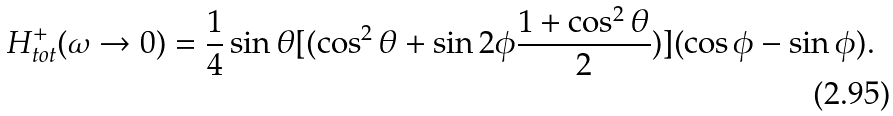Convert formula to latex. <formula><loc_0><loc_0><loc_500><loc_500>H _ { t o t } ^ { + } ( \omega \rightarrow 0 ) = \frac { 1 } { 4 } \sin \theta [ ( \cos ^ { 2 } \theta + \sin 2 \phi \frac { 1 + \cos ^ { 2 } \theta } { 2 } ) ] ( \cos \phi - \sin \phi ) .</formula> 